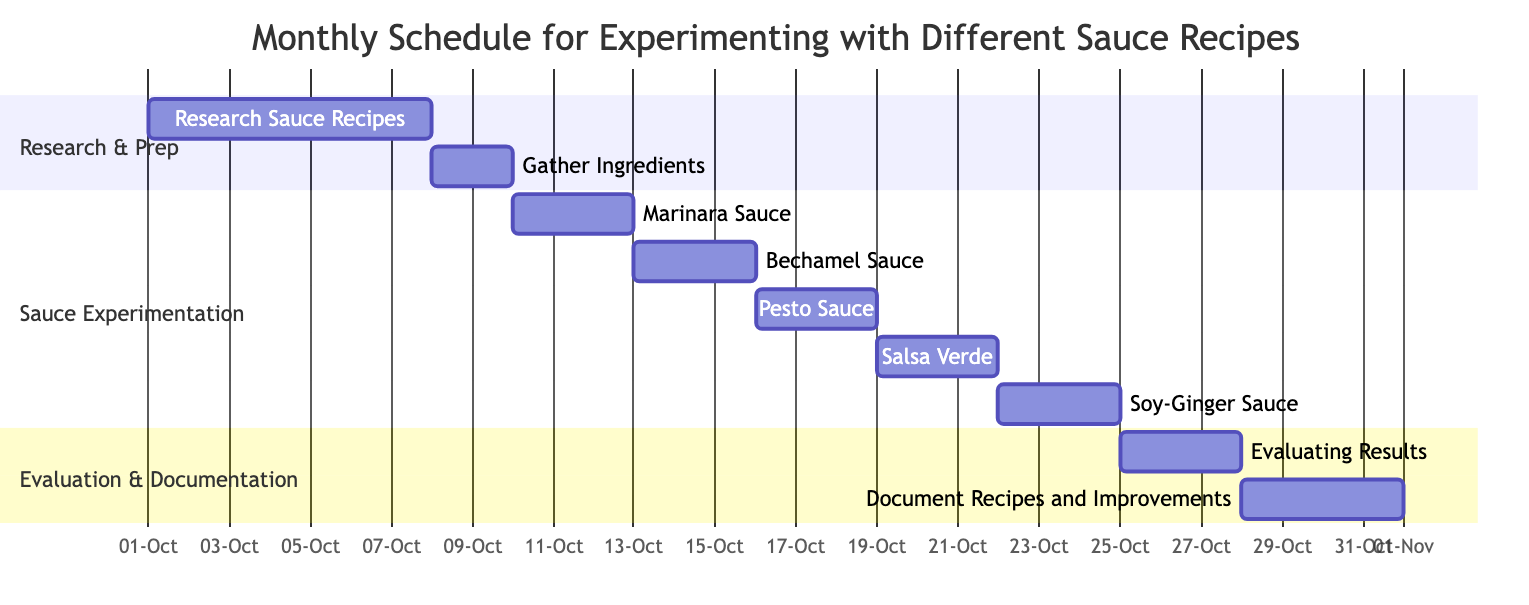What is the first task listed in the schedule? The first task in the Gantt chart is "Research Sauce Recipes," which starts on October 1, 2023.
Answer: Research Sauce Recipes How many days is dedicated to Marinara Sauce Experimentation? The Marinara Sauce Experimentation lasts for 3 days, starting on October 10 and ending on October 12.
Answer: 3 days Which sauce experimentation occurs after Pesto Sauce? The task following Pesto Sauce Experimentation is Salsa Verde Experimentation, which starts on October 19.
Answer: Salsa Verde Experimentation What is the total number of tasks in this schedule? The schedule comprises nine tasks spanning research, experimentation, evaluation, and documentation.
Answer: 9 During which time frame is the "Evaluating Results" task scheduled? Evaluating Results is scheduled to occur from October 25 to October 27, 2023, lasting for 3 days.
Answer: October 25 to October 27 Which task directly follows the "Gather Ingredients" task? The task that directly follows "Gather Ingredients" is "Marinara Sauce Experimentation," which starts right after (on October 10).
Answer: Marinara Sauce Experimentation What is the duration of the last task called "Document Recipes and Improvements"? The last task, Document Recipes and Improvements, spans 4 days, starting from October 28 to October 31, 2023.
Answer: 4 days How many sections are there in the Gantt chart? The Gantt chart is divided into three sections: Research & Prep, Sauce Experimentation, and Evaluation & Documentation.
Answer: 3 sections What is the starting date for experimenting with Soy-Ginger Sauce? The Soy-Ginger Sauce Experimentation starts on October 22, 2023, as it is scheduled after Salsa Verde.
Answer: October 22 